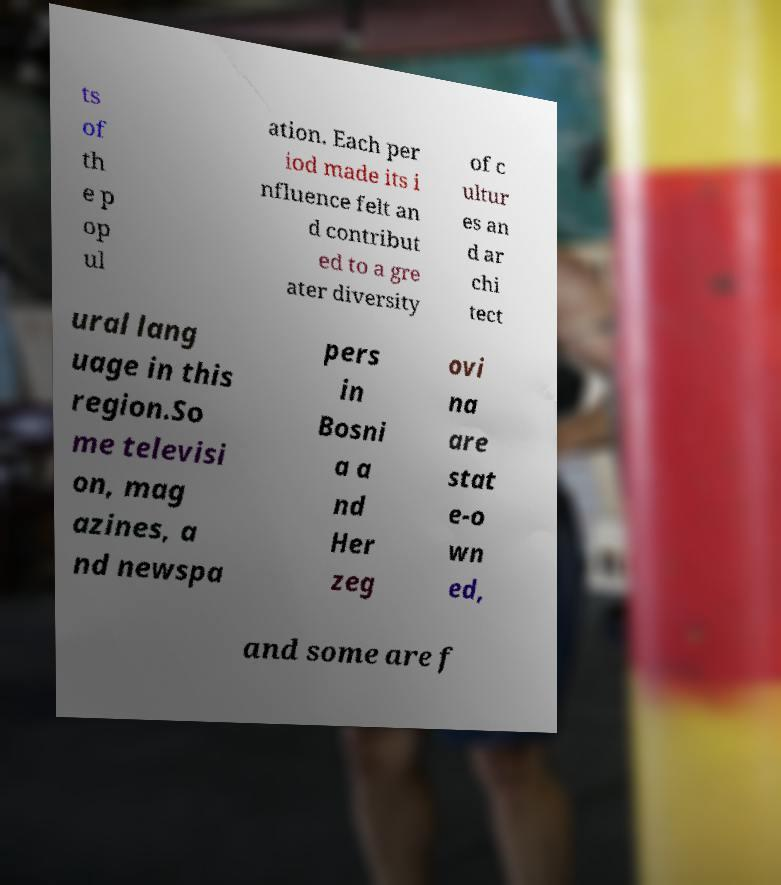Please read and relay the text visible in this image. What does it say? ts of th e p op ul ation. Each per iod made its i nfluence felt an d contribut ed to a gre ater diversity of c ultur es an d ar chi tect ural lang uage in this region.So me televisi on, mag azines, a nd newspa pers in Bosni a a nd Her zeg ovi na are stat e-o wn ed, and some are f 